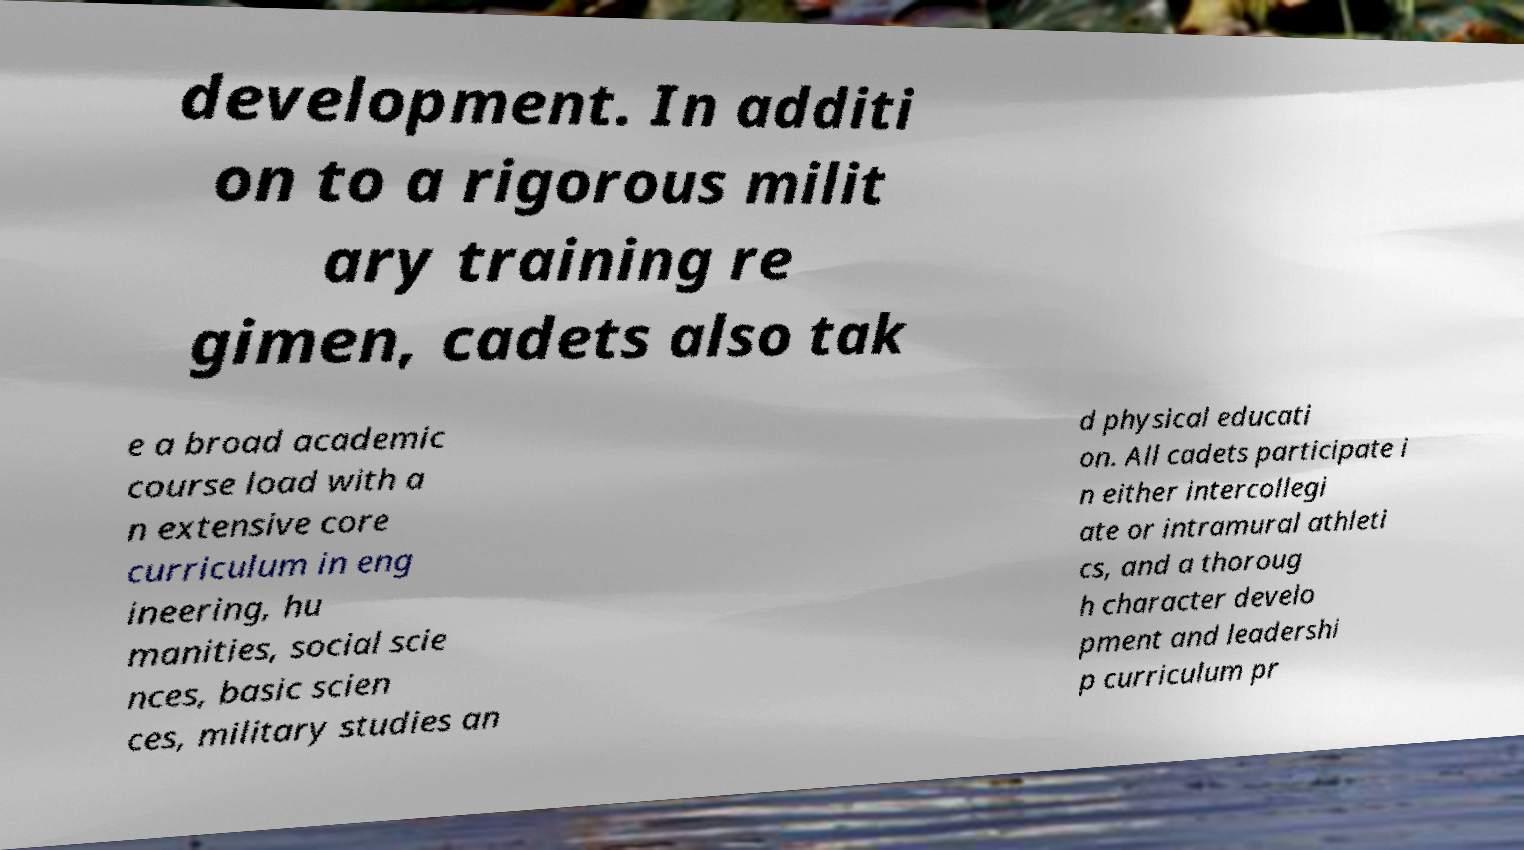Could you assist in decoding the text presented in this image and type it out clearly? development. In additi on to a rigorous milit ary training re gimen, cadets also tak e a broad academic course load with a n extensive core curriculum in eng ineering, hu manities, social scie nces, basic scien ces, military studies an d physical educati on. All cadets participate i n either intercollegi ate or intramural athleti cs, and a thoroug h character develo pment and leadershi p curriculum pr 